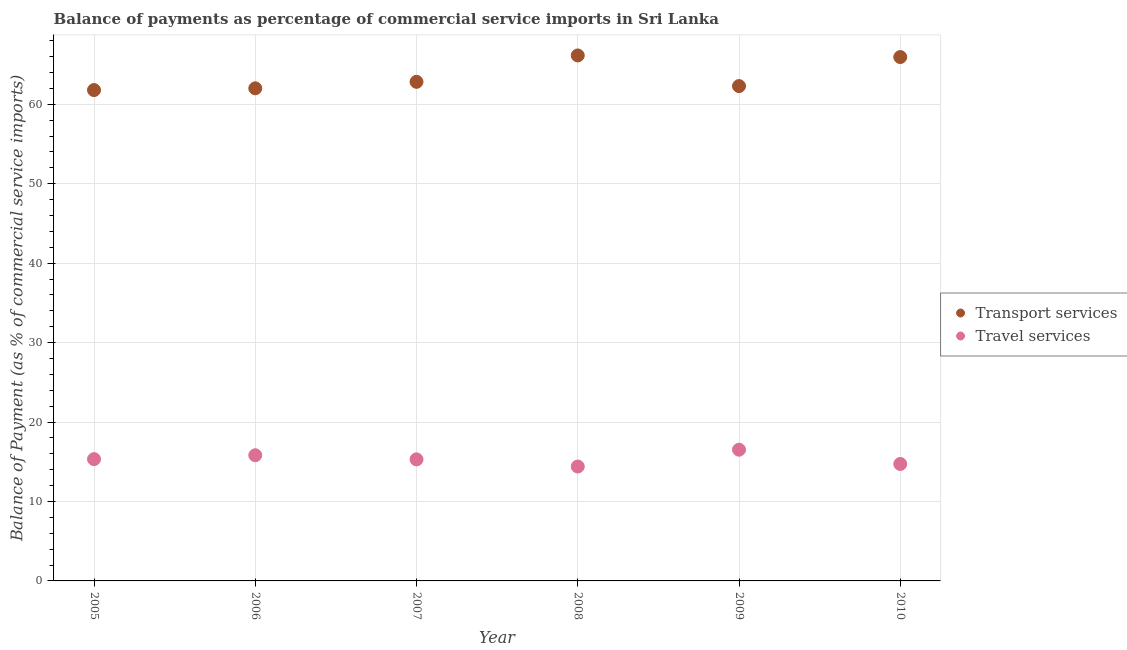How many different coloured dotlines are there?
Keep it short and to the point. 2. Is the number of dotlines equal to the number of legend labels?
Ensure brevity in your answer.  Yes. What is the balance of payments of transport services in 2006?
Provide a short and direct response. 62.01. Across all years, what is the maximum balance of payments of travel services?
Provide a short and direct response. 16.52. Across all years, what is the minimum balance of payments of transport services?
Provide a succinct answer. 61.79. In which year was the balance of payments of travel services maximum?
Offer a terse response. 2009. What is the total balance of payments of travel services in the graph?
Your answer should be very brief. 92.09. What is the difference between the balance of payments of travel services in 2007 and that in 2009?
Ensure brevity in your answer.  -1.22. What is the difference between the balance of payments of transport services in 2007 and the balance of payments of travel services in 2005?
Ensure brevity in your answer.  47.49. What is the average balance of payments of transport services per year?
Provide a short and direct response. 63.5. In the year 2007, what is the difference between the balance of payments of transport services and balance of payments of travel services?
Provide a short and direct response. 47.52. What is the ratio of the balance of payments of travel services in 2007 to that in 2009?
Keep it short and to the point. 0.93. Is the balance of payments of travel services in 2006 less than that in 2007?
Your answer should be very brief. No. Is the difference between the balance of payments of transport services in 2007 and 2008 greater than the difference between the balance of payments of travel services in 2007 and 2008?
Ensure brevity in your answer.  No. What is the difference between the highest and the second highest balance of payments of transport services?
Give a very brief answer. 0.2. What is the difference between the highest and the lowest balance of payments of travel services?
Your response must be concise. 2.12. Is the sum of the balance of payments of travel services in 2006 and 2010 greater than the maximum balance of payments of transport services across all years?
Keep it short and to the point. No. Is the balance of payments of travel services strictly greater than the balance of payments of transport services over the years?
Make the answer very short. No. Is the balance of payments of transport services strictly less than the balance of payments of travel services over the years?
Your answer should be very brief. No. How many years are there in the graph?
Provide a short and direct response. 6. What is the difference between two consecutive major ticks on the Y-axis?
Your answer should be compact. 10. Does the graph contain grids?
Your response must be concise. Yes. How are the legend labels stacked?
Your answer should be very brief. Vertical. What is the title of the graph?
Provide a succinct answer. Balance of payments as percentage of commercial service imports in Sri Lanka. What is the label or title of the Y-axis?
Your response must be concise. Balance of Payment (as % of commercial service imports). What is the Balance of Payment (as % of commercial service imports) of Transport services in 2005?
Keep it short and to the point. 61.79. What is the Balance of Payment (as % of commercial service imports) of Travel services in 2005?
Ensure brevity in your answer.  15.33. What is the Balance of Payment (as % of commercial service imports) of Transport services in 2006?
Give a very brief answer. 62.01. What is the Balance of Payment (as % of commercial service imports) in Travel services in 2006?
Provide a short and direct response. 15.82. What is the Balance of Payment (as % of commercial service imports) in Transport services in 2007?
Your response must be concise. 62.82. What is the Balance of Payment (as % of commercial service imports) in Travel services in 2007?
Give a very brief answer. 15.3. What is the Balance of Payment (as % of commercial service imports) in Transport services in 2008?
Offer a very short reply. 66.15. What is the Balance of Payment (as % of commercial service imports) in Travel services in 2008?
Your answer should be very brief. 14.4. What is the Balance of Payment (as % of commercial service imports) of Transport services in 2009?
Your answer should be very brief. 62.29. What is the Balance of Payment (as % of commercial service imports) of Travel services in 2009?
Your answer should be very brief. 16.52. What is the Balance of Payment (as % of commercial service imports) in Transport services in 2010?
Provide a succinct answer. 65.94. What is the Balance of Payment (as % of commercial service imports) in Travel services in 2010?
Provide a short and direct response. 14.72. Across all years, what is the maximum Balance of Payment (as % of commercial service imports) in Transport services?
Your answer should be compact. 66.15. Across all years, what is the maximum Balance of Payment (as % of commercial service imports) of Travel services?
Your response must be concise. 16.52. Across all years, what is the minimum Balance of Payment (as % of commercial service imports) of Transport services?
Make the answer very short. 61.79. Across all years, what is the minimum Balance of Payment (as % of commercial service imports) of Travel services?
Provide a succinct answer. 14.4. What is the total Balance of Payment (as % of commercial service imports) in Transport services in the graph?
Your answer should be very brief. 381. What is the total Balance of Payment (as % of commercial service imports) of Travel services in the graph?
Your answer should be very brief. 92.09. What is the difference between the Balance of Payment (as % of commercial service imports) of Transport services in 2005 and that in 2006?
Keep it short and to the point. -0.22. What is the difference between the Balance of Payment (as % of commercial service imports) in Travel services in 2005 and that in 2006?
Offer a very short reply. -0.49. What is the difference between the Balance of Payment (as % of commercial service imports) of Transport services in 2005 and that in 2007?
Ensure brevity in your answer.  -1.04. What is the difference between the Balance of Payment (as % of commercial service imports) of Travel services in 2005 and that in 2007?
Offer a very short reply. 0.03. What is the difference between the Balance of Payment (as % of commercial service imports) of Transport services in 2005 and that in 2008?
Make the answer very short. -4.36. What is the difference between the Balance of Payment (as % of commercial service imports) of Travel services in 2005 and that in 2008?
Offer a terse response. 0.93. What is the difference between the Balance of Payment (as % of commercial service imports) in Transport services in 2005 and that in 2009?
Provide a succinct answer. -0.5. What is the difference between the Balance of Payment (as % of commercial service imports) of Travel services in 2005 and that in 2009?
Your response must be concise. -1.19. What is the difference between the Balance of Payment (as % of commercial service imports) in Transport services in 2005 and that in 2010?
Offer a very short reply. -4.16. What is the difference between the Balance of Payment (as % of commercial service imports) of Travel services in 2005 and that in 2010?
Ensure brevity in your answer.  0.61. What is the difference between the Balance of Payment (as % of commercial service imports) in Transport services in 2006 and that in 2007?
Your answer should be compact. -0.82. What is the difference between the Balance of Payment (as % of commercial service imports) in Travel services in 2006 and that in 2007?
Ensure brevity in your answer.  0.52. What is the difference between the Balance of Payment (as % of commercial service imports) of Transport services in 2006 and that in 2008?
Make the answer very short. -4.14. What is the difference between the Balance of Payment (as % of commercial service imports) in Travel services in 2006 and that in 2008?
Keep it short and to the point. 1.42. What is the difference between the Balance of Payment (as % of commercial service imports) of Transport services in 2006 and that in 2009?
Give a very brief answer. -0.28. What is the difference between the Balance of Payment (as % of commercial service imports) of Travel services in 2006 and that in 2009?
Provide a short and direct response. -0.7. What is the difference between the Balance of Payment (as % of commercial service imports) in Transport services in 2006 and that in 2010?
Provide a succinct answer. -3.94. What is the difference between the Balance of Payment (as % of commercial service imports) in Travel services in 2006 and that in 2010?
Your answer should be compact. 1.1. What is the difference between the Balance of Payment (as % of commercial service imports) in Transport services in 2007 and that in 2008?
Ensure brevity in your answer.  -3.32. What is the difference between the Balance of Payment (as % of commercial service imports) of Travel services in 2007 and that in 2008?
Your answer should be very brief. 0.9. What is the difference between the Balance of Payment (as % of commercial service imports) of Transport services in 2007 and that in 2009?
Your answer should be very brief. 0.54. What is the difference between the Balance of Payment (as % of commercial service imports) in Travel services in 2007 and that in 2009?
Offer a very short reply. -1.22. What is the difference between the Balance of Payment (as % of commercial service imports) in Transport services in 2007 and that in 2010?
Keep it short and to the point. -3.12. What is the difference between the Balance of Payment (as % of commercial service imports) in Travel services in 2007 and that in 2010?
Your response must be concise. 0.58. What is the difference between the Balance of Payment (as % of commercial service imports) of Transport services in 2008 and that in 2009?
Provide a succinct answer. 3.86. What is the difference between the Balance of Payment (as % of commercial service imports) in Travel services in 2008 and that in 2009?
Ensure brevity in your answer.  -2.12. What is the difference between the Balance of Payment (as % of commercial service imports) of Transport services in 2008 and that in 2010?
Keep it short and to the point. 0.2. What is the difference between the Balance of Payment (as % of commercial service imports) in Travel services in 2008 and that in 2010?
Your answer should be compact. -0.32. What is the difference between the Balance of Payment (as % of commercial service imports) of Transport services in 2009 and that in 2010?
Give a very brief answer. -3.65. What is the difference between the Balance of Payment (as % of commercial service imports) in Travel services in 2009 and that in 2010?
Make the answer very short. 1.8. What is the difference between the Balance of Payment (as % of commercial service imports) in Transport services in 2005 and the Balance of Payment (as % of commercial service imports) in Travel services in 2006?
Your answer should be very brief. 45.97. What is the difference between the Balance of Payment (as % of commercial service imports) in Transport services in 2005 and the Balance of Payment (as % of commercial service imports) in Travel services in 2007?
Your answer should be very brief. 46.49. What is the difference between the Balance of Payment (as % of commercial service imports) of Transport services in 2005 and the Balance of Payment (as % of commercial service imports) of Travel services in 2008?
Make the answer very short. 47.39. What is the difference between the Balance of Payment (as % of commercial service imports) in Transport services in 2005 and the Balance of Payment (as % of commercial service imports) in Travel services in 2009?
Provide a succinct answer. 45.27. What is the difference between the Balance of Payment (as % of commercial service imports) of Transport services in 2005 and the Balance of Payment (as % of commercial service imports) of Travel services in 2010?
Ensure brevity in your answer.  47.07. What is the difference between the Balance of Payment (as % of commercial service imports) in Transport services in 2006 and the Balance of Payment (as % of commercial service imports) in Travel services in 2007?
Ensure brevity in your answer.  46.71. What is the difference between the Balance of Payment (as % of commercial service imports) in Transport services in 2006 and the Balance of Payment (as % of commercial service imports) in Travel services in 2008?
Ensure brevity in your answer.  47.61. What is the difference between the Balance of Payment (as % of commercial service imports) in Transport services in 2006 and the Balance of Payment (as % of commercial service imports) in Travel services in 2009?
Provide a short and direct response. 45.49. What is the difference between the Balance of Payment (as % of commercial service imports) in Transport services in 2006 and the Balance of Payment (as % of commercial service imports) in Travel services in 2010?
Keep it short and to the point. 47.29. What is the difference between the Balance of Payment (as % of commercial service imports) of Transport services in 2007 and the Balance of Payment (as % of commercial service imports) of Travel services in 2008?
Make the answer very short. 48.42. What is the difference between the Balance of Payment (as % of commercial service imports) in Transport services in 2007 and the Balance of Payment (as % of commercial service imports) in Travel services in 2009?
Your response must be concise. 46.3. What is the difference between the Balance of Payment (as % of commercial service imports) of Transport services in 2007 and the Balance of Payment (as % of commercial service imports) of Travel services in 2010?
Ensure brevity in your answer.  48.1. What is the difference between the Balance of Payment (as % of commercial service imports) of Transport services in 2008 and the Balance of Payment (as % of commercial service imports) of Travel services in 2009?
Ensure brevity in your answer.  49.63. What is the difference between the Balance of Payment (as % of commercial service imports) in Transport services in 2008 and the Balance of Payment (as % of commercial service imports) in Travel services in 2010?
Provide a succinct answer. 51.43. What is the difference between the Balance of Payment (as % of commercial service imports) of Transport services in 2009 and the Balance of Payment (as % of commercial service imports) of Travel services in 2010?
Offer a terse response. 47.57. What is the average Balance of Payment (as % of commercial service imports) of Transport services per year?
Offer a terse response. 63.5. What is the average Balance of Payment (as % of commercial service imports) of Travel services per year?
Ensure brevity in your answer.  15.35. In the year 2005, what is the difference between the Balance of Payment (as % of commercial service imports) of Transport services and Balance of Payment (as % of commercial service imports) of Travel services?
Provide a short and direct response. 46.46. In the year 2006, what is the difference between the Balance of Payment (as % of commercial service imports) in Transport services and Balance of Payment (as % of commercial service imports) in Travel services?
Ensure brevity in your answer.  46.19. In the year 2007, what is the difference between the Balance of Payment (as % of commercial service imports) in Transport services and Balance of Payment (as % of commercial service imports) in Travel services?
Give a very brief answer. 47.52. In the year 2008, what is the difference between the Balance of Payment (as % of commercial service imports) in Transport services and Balance of Payment (as % of commercial service imports) in Travel services?
Your answer should be compact. 51.75. In the year 2009, what is the difference between the Balance of Payment (as % of commercial service imports) of Transport services and Balance of Payment (as % of commercial service imports) of Travel services?
Your response must be concise. 45.77. In the year 2010, what is the difference between the Balance of Payment (as % of commercial service imports) of Transport services and Balance of Payment (as % of commercial service imports) of Travel services?
Provide a succinct answer. 51.22. What is the ratio of the Balance of Payment (as % of commercial service imports) in Transport services in 2005 to that in 2006?
Your answer should be very brief. 1. What is the ratio of the Balance of Payment (as % of commercial service imports) in Transport services in 2005 to that in 2007?
Make the answer very short. 0.98. What is the ratio of the Balance of Payment (as % of commercial service imports) in Travel services in 2005 to that in 2007?
Your response must be concise. 1. What is the ratio of the Balance of Payment (as % of commercial service imports) in Transport services in 2005 to that in 2008?
Offer a terse response. 0.93. What is the ratio of the Balance of Payment (as % of commercial service imports) of Travel services in 2005 to that in 2008?
Your answer should be compact. 1.06. What is the ratio of the Balance of Payment (as % of commercial service imports) in Transport services in 2005 to that in 2009?
Provide a short and direct response. 0.99. What is the ratio of the Balance of Payment (as % of commercial service imports) of Travel services in 2005 to that in 2009?
Offer a very short reply. 0.93. What is the ratio of the Balance of Payment (as % of commercial service imports) in Transport services in 2005 to that in 2010?
Provide a short and direct response. 0.94. What is the ratio of the Balance of Payment (as % of commercial service imports) in Travel services in 2005 to that in 2010?
Your response must be concise. 1.04. What is the ratio of the Balance of Payment (as % of commercial service imports) in Transport services in 2006 to that in 2007?
Your answer should be very brief. 0.99. What is the ratio of the Balance of Payment (as % of commercial service imports) in Travel services in 2006 to that in 2007?
Your response must be concise. 1.03. What is the ratio of the Balance of Payment (as % of commercial service imports) of Transport services in 2006 to that in 2008?
Offer a terse response. 0.94. What is the ratio of the Balance of Payment (as % of commercial service imports) of Travel services in 2006 to that in 2008?
Offer a very short reply. 1.1. What is the ratio of the Balance of Payment (as % of commercial service imports) in Transport services in 2006 to that in 2009?
Make the answer very short. 1. What is the ratio of the Balance of Payment (as % of commercial service imports) of Travel services in 2006 to that in 2009?
Provide a succinct answer. 0.96. What is the ratio of the Balance of Payment (as % of commercial service imports) of Transport services in 2006 to that in 2010?
Your answer should be very brief. 0.94. What is the ratio of the Balance of Payment (as % of commercial service imports) in Travel services in 2006 to that in 2010?
Offer a very short reply. 1.07. What is the ratio of the Balance of Payment (as % of commercial service imports) of Transport services in 2007 to that in 2008?
Offer a very short reply. 0.95. What is the ratio of the Balance of Payment (as % of commercial service imports) of Travel services in 2007 to that in 2008?
Offer a terse response. 1.06. What is the ratio of the Balance of Payment (as % of commercial service imports) in Transport services in 2007 to that in 2009?
Make the answer very short. 1.01. What is the ratio of the Balance of Payment (as % of commercial service imports) in Travel services in 2007 to that in 2009?
Offer a terse response. 0.93. What is the ratio of the Balance of Payment (as % of commercial service imports) in Transport services in 2007 to that in 2010?
Provide a succinct answer. 0.95. What is the ratio of the Balance of Payment (as % of commercial service imports) of Travel services in 2007 to that in 2010?
Your response must be concise. 1.04. What is the ratio of the Balance of Payment (as % of commercial service imports) of Transport services in 2008 to that in 2009?
Your answer should be very brief. 1.06. What is the ratio of the Balance of Payment (as % of commercial service imports) in Travel services in 2008 to that in 2009?
Give a very brief answer. 0.87. What is the ratio of the Balance of Payment (as % of commercial service imports) of Transport services in 2008 to that in 2010?
Provide a short and direct response. 1. What is the ratio of the Balance of Payment (as % of commercial service imports) of Travel services in 2008 to that in 2010?
Your response must be concise. 0.98. What is the ratio of the Balance of Payment (as % of commercial service imports) of Transport services in 2009 to that in 2010?
Ensure brevity in your answer.  0.94. What is the ratio of the Balance of Payment (as % of commercial service imports) of Travel services in 2009 to that in 2010?
Provide a succinct answer. 1.12. What is the difference between the highest and the second highest Balance of Payment (as % of commercial service imports) in Transport services?
Give a very brief answer. 0.2. What is the difference between the highest and the second highest Balance of Payment (as % of commercial service imports) of Travel services?
Your answer should be compact. 0.7. What is the difference between the highest and the lowest Balance of Payment (as % of commercial service imports) of Transport services?
Keep it short and to the point. 4.36. What is the difference between the highest and the lowest Balance of Payment (as % of commercial service imports) in Travel services?
Make the answer very short. 2.12. 